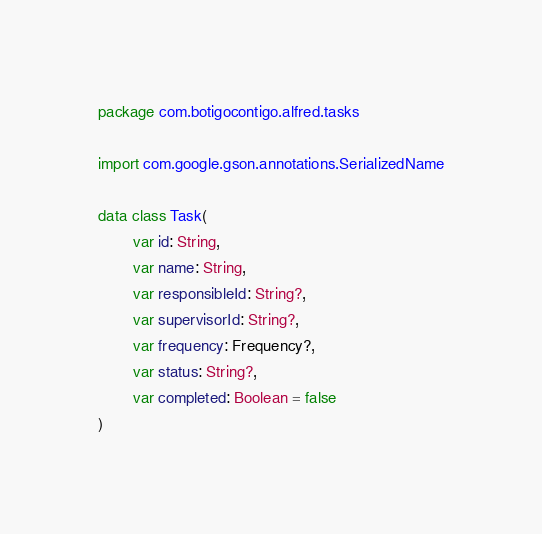<code> <loc_0><loc_0><loc_500><loc_500><_Kotlin_>package com.botigocontigo.alfred.tasks

import com.google.gson.annotations.SerializedName

data class Task(
        var id: String,
        var name: String,
        var responsibleId: String?,
        var supervisorId: String?,
        var frequency: Frequency?,
        var status: String?,
        var completed: Boolean = false
)</code> 